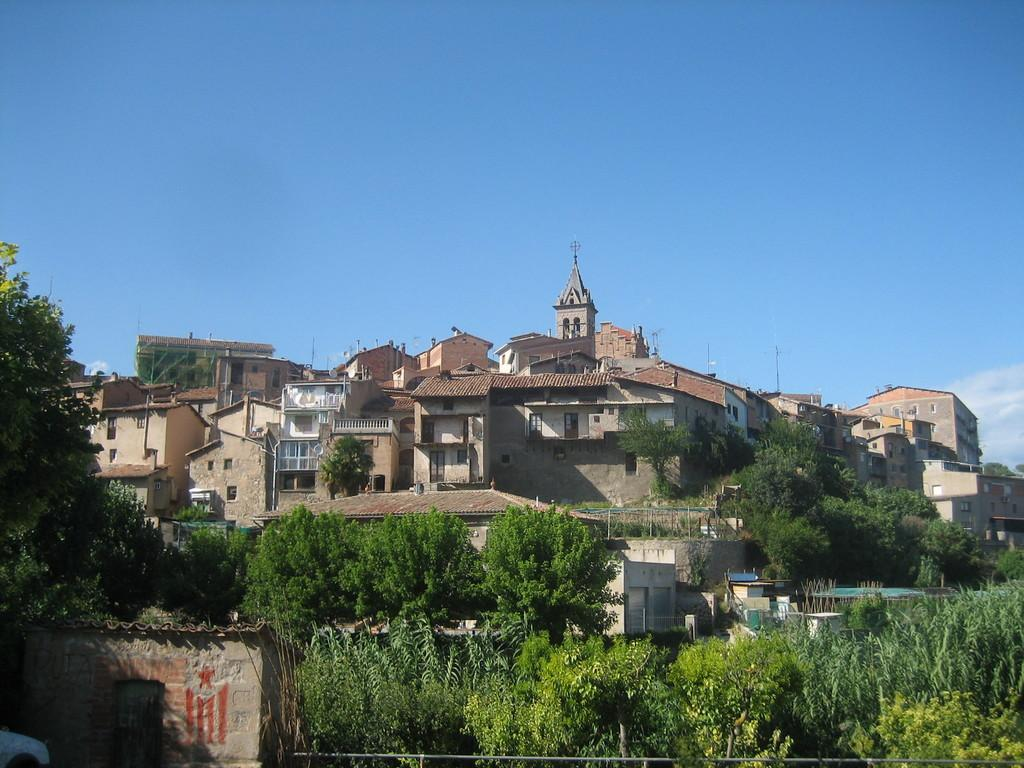What type of structures can be seen in the image? There are many houses in the image in the image. What is visible at the top of the image? The sky is visible at the top of the image. What type of vegetation is present in the image? There are plants and trees in the front of the image. What is located on the left side of the image? There is a small room on the left side of the image. Can you see any holes in the ground in the image? There is no mention of any holes in the ground in the image. What type of animal can be seen in the small room on the left side of the image? There is no animal present in the small room or any other part of the image. 